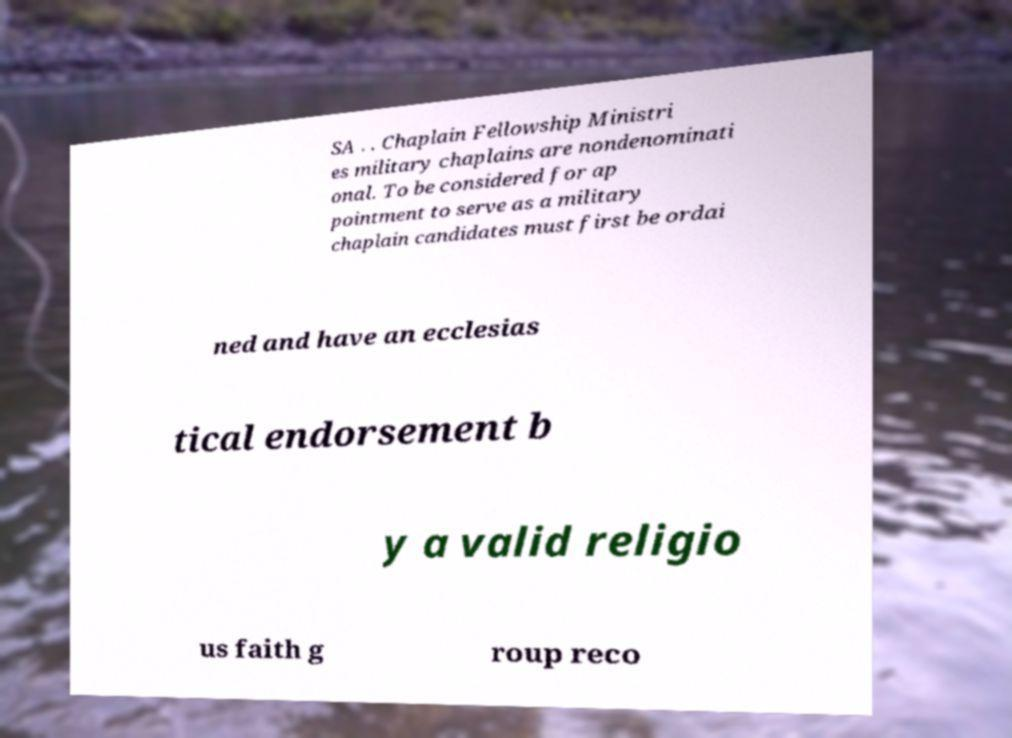Please identify and transcribe the text found in this image. SA . . Chaplain Fellowship Ministri es military chaplains are nondenominati onal. To be considered for ap pointment to serve as a military chaplain candidates must first be ordai ned and have an ecclesias tical endorsement b y a valid religio us faith g roup reco 